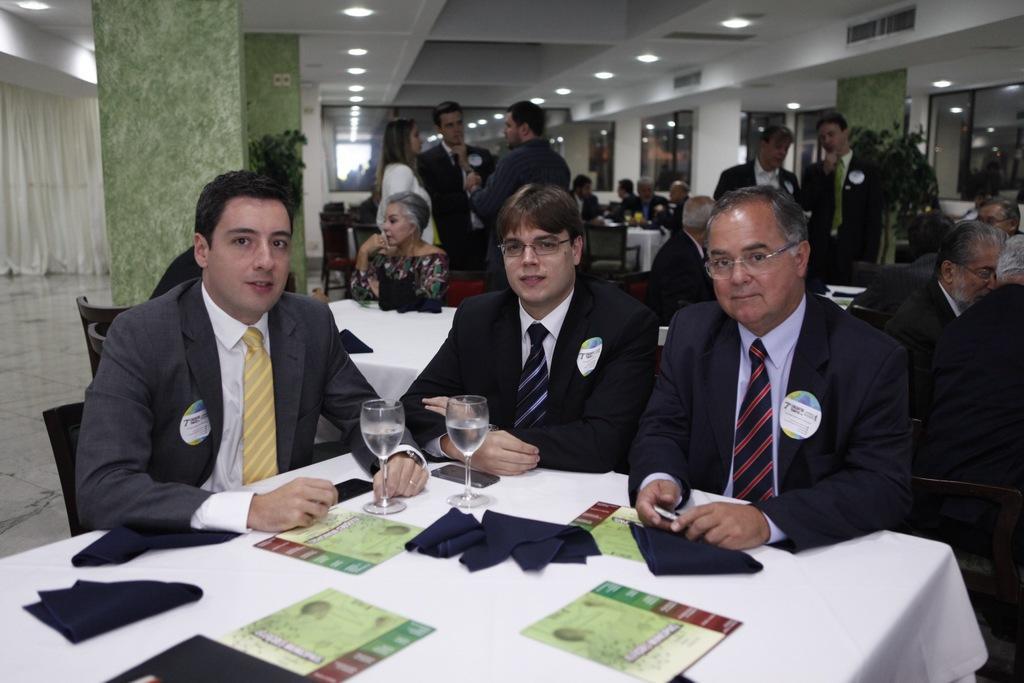In one or two sentences, can you explain what this image depicts? In the center we can see three persons were sitting around the table. On table we can see two glasses,paper,napkin. And coming to background we can see few persons were standing and few persons were sitting around the table. And we can see lights,wall and plant,curtain and some objects around them. 